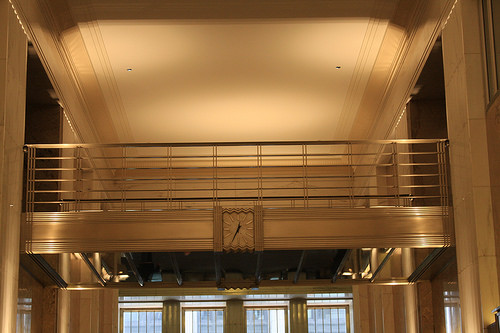<image>
Is there a clock under the balcony? Yes. The clock is positioned underneath the balcony, with the balcony above it in the vertical space. 